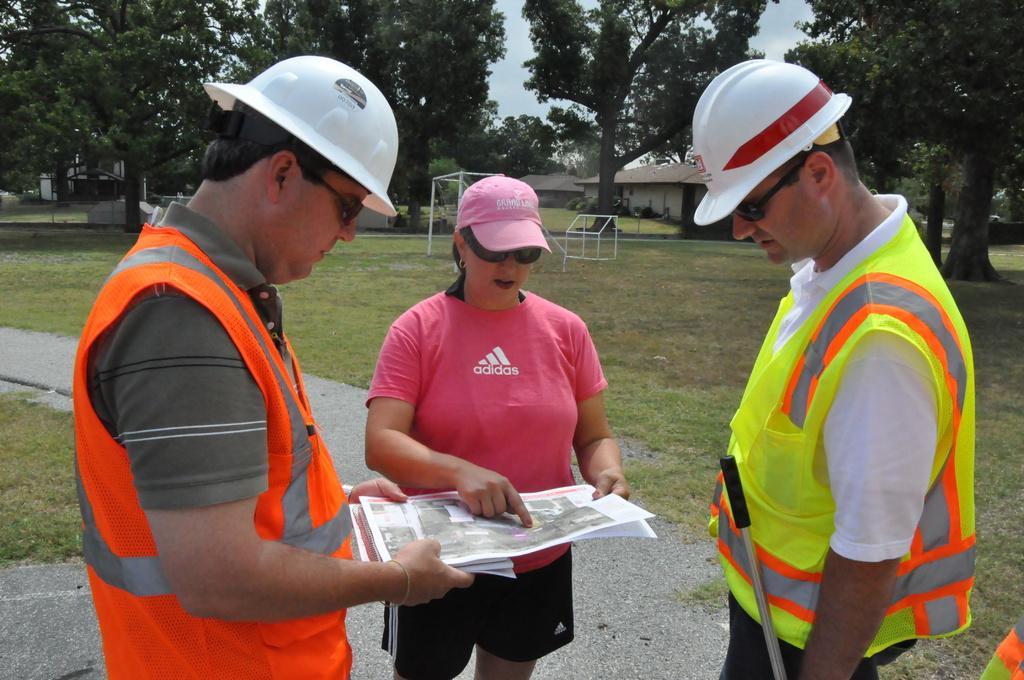How would you summarize this image in a sentence or two? In the image there are three people standing in a ground and the woman who is standing in the middle is explaining something from a paper and around them there are plenty of trees and two houses. 